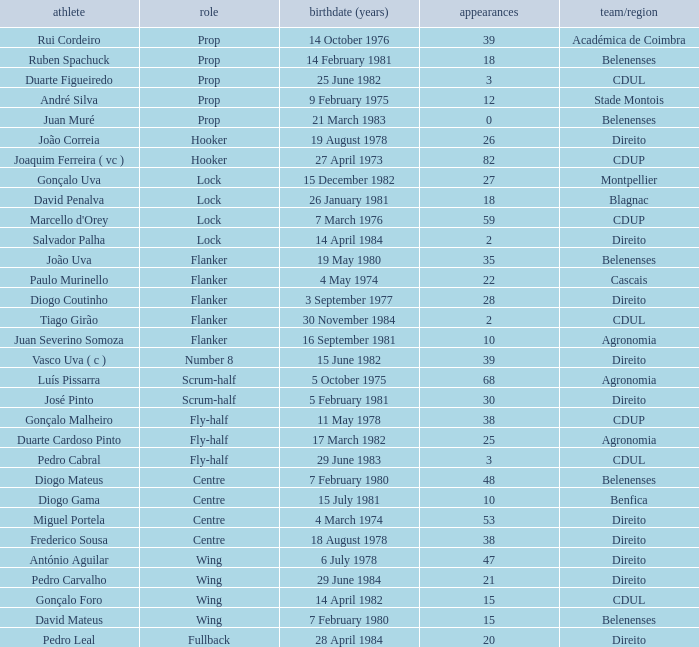Which player has a Position of fly-half, and a Caps of 3? Pedro Cabral. 